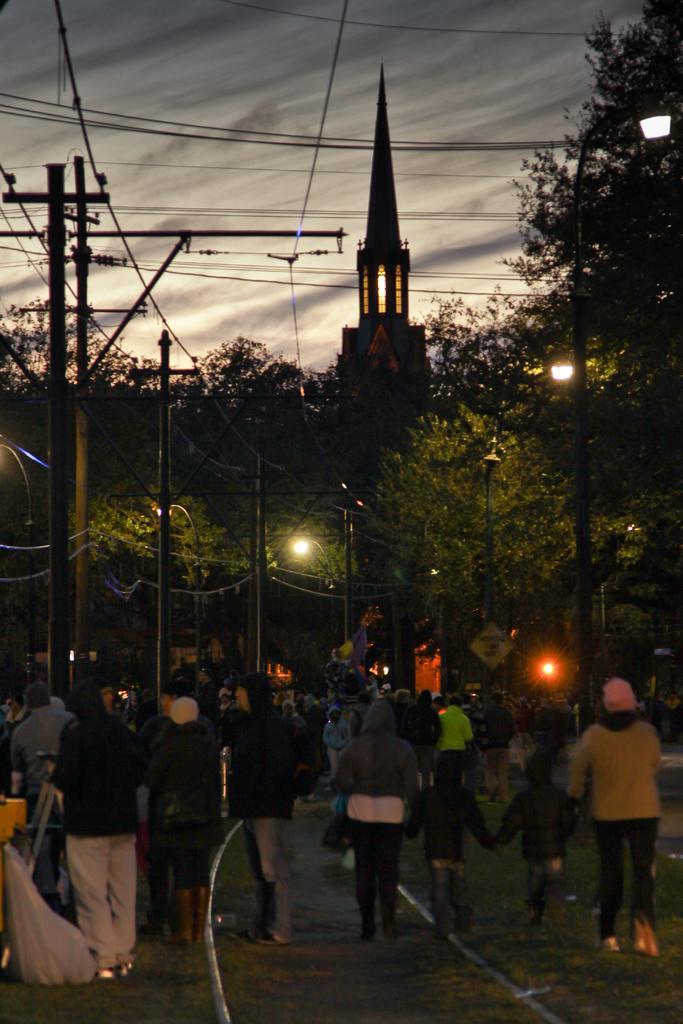Describe this image in one or two sentences. In this image I can see there are few standing, few people walking on the road, in the middle there are power line cables, light pole, tower, trees visible ,at the top there is the sky. 